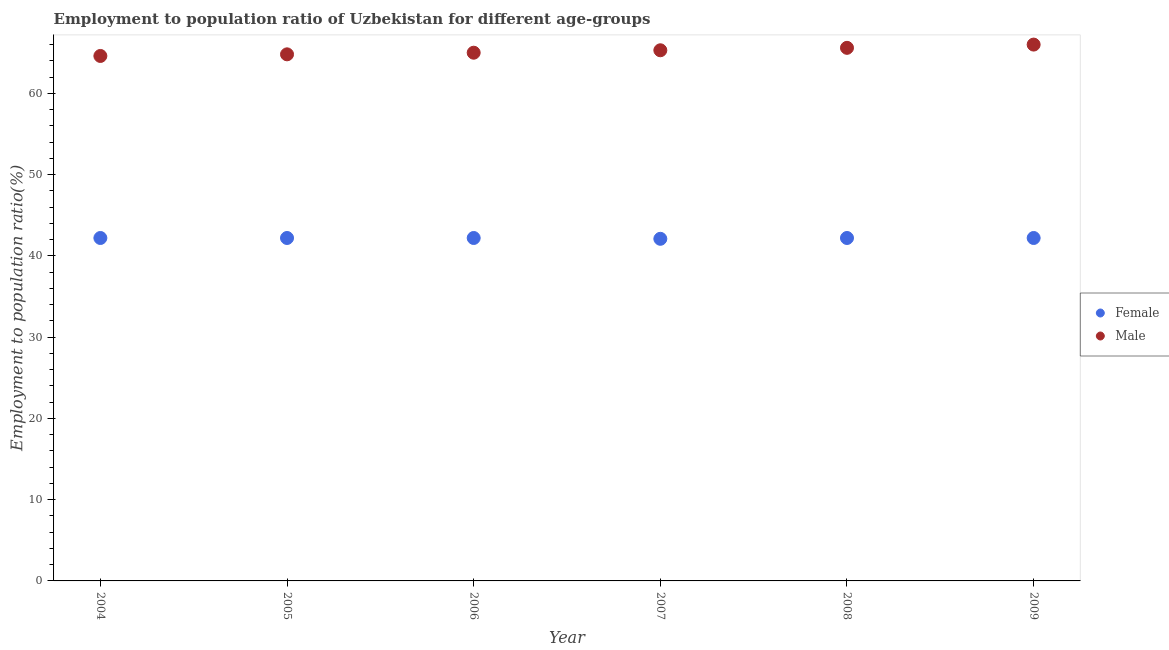Is the number of dotlines equal to the number of legend labels?
Provide a succinct answer. Yes. What is the employment to population ratio(female) in 2006?
Make the answer very short. 42.2. Across all years, what is the minimum employment to population ratio(male)?
Give a very brief answer. 64.6. In which year was the employment to population ratio(male) minimum?
Give a very brief answer. 2004. What is the total employment to population ratio(female) in the graph?
Ensure brevity in your answer.  253.1. What is the difference between the employment to population ratio(female) in 2006 and that in 2008?
Provide a succinct answer. 0. What is the difference between the employment to population ratio(male) in 2007 and the employment to population ratio(female) in 2008?
Provide a short and direct response. 23.1. What is the average employment to population ratio(female) per year?
Your response must be concise. 42.18. In the year 2004, what is the difference between the employment to population ratio(female) and employment to population ratio(male)?
Ensure brevity in your answer.  -22.4. What is the ratio of the employment to population ratio(male) in 2007 to that in 2009?
Keep it short and to the point. 0.99. Is the employment to population ratio(male) in 2004 less than that in 2009?
Provide a succinct answer. Yes. Is the difference between the employment to population ratio(male) in 2007 and 2008 greater than the difference between the employment to population ratio(female) in 2007 and 2008?
Your answer should be very brief. No. What is the difference between the highest and the second highest employment to population ratio(male)?
Give a very brief answer. 0.4. What is the difference between the highest and the lowest employment to population ratio(female)?
Keep it short and to the point. 0.1. Does the employment to population ratio(male) monotonically increase over the years?
Provide a succinct answer. Yes. How many years are there in the graph?
Offer a very short reply. 6. What is the difference between two consecutive major ticks on the Y-axis?
Offer a very short reply. 10. Does the graph contain any zero values?
Offer a very short reply. No. Does the graph contain grids?
Offer a terse response. No. Where does the legend appear in the graph?
Provide a short and direct response. Center right. How are the legend labels stacked?
Ensure brevity in your answer.  Vertical. What is the title of the graph?
Offer a terse response. Employment to population ratio of Uzbekistan for different age-groups. Does "Quality of trade" appear as one of the legend labels in the graph?
Make the answer very short. No. What is the label or title of the X-axis?
Make the answer very short. Year. What is the Employment to population ratio(%) in Female in 2004?
Your response must be concise. 42.2. What is the Employment to population ratio(%) in Male in 2004?
Offer a terse response. 64.6. What is the Employment to population ratio(%) of Female in 2005?
Give a very brief answer. 42.2. What is the Employment to population ratio(%) in Male in 2005?
Provide a succinct answer. 64.8. What is the Employment to population ratio(%) of Female in 2006?
Your answer should be compact. 42.2. What is the Employment to population ratio(%) in Male in 2006?
Offer a terse response. 65. What is the Employment to population ratio(%) in Female in 2007?
Offer a very short reply. 42.1. What is the Employment to population ratio(%) in Male in 2007?
Give a very brief answer. 65.3. What is the Employment to population ratio(%) of Female in 2008?
Keep it short and to the point. 42.2. What is the Employment to population ratio(%) in Male in 2008?
Your response must be concise. 65.6. What is the Employment to population ratio(%) in Female in 2009?
Your response must be concise. 42.2. Across all years, what is the maximum Employment to population ratio(%) of Female?
Ensure brevity in your answer.  42.2. Across all years, what is the maximum Employment to population ratio(%) of Male?
Your answer should be compact. 66. Across all years, what is the minimum Employment to population ratio(%) in Female?
Provide a succinct answer. 42.1. Across all years, what is the minimum Employment to population ratio(%) of Male?
Provide a short and direct response. 64.6. What is the total Employment to population ratio(%) of Female in the graph?
Offer a very short reply. 253.1. What is the total Employment to population ratio(%) in Male in the graph?
Offer a terse response. 391.3. What is the difference between the Employment to population ratio(%) of Female in 2004 and that in 2005?
Provide a succinct answer. 0. What is the difference between the Employment to population ratio(%) of Male in 2004 and that in 2005?
Ensure brevity in your answer.  -0.2. What is the difference between the Employment to population ratio(%) in Female in 2004 and that in 2006?
Give a very brief answer. 0. What is the difference between the Employment to population ratio(%) in Male in 2004 and that in 2007?
Provide a short and direct response. -0.7. What is the difference between the Employment to population ratio(%) in Male in 2004 and that in 2008?
Offer a terse response. -1. What is the difference between the Employment to population ratio(%) in Female in 2005 and that in 2006?
Your answer should be compact. 0. What is the difference between the Employment to population ratio(%) of Male in 2005 and that in 2006?
Your answer should be very brief. -0.2. What is the difference between the Employment to population ratio(%) of Male in 2005 and that in 2008?
Offer a terse response. -0.8. What is the difference between the Employment to population ratio(%) in Male in 2005 and that in 2009?
Keep it short and to the point. -1.2. What is the difference between the Employment to population ratio(%) in Female in 2006 and that in 2007?
Offer a very short reply. 0.1. What is the difference between the Employment to population ratio(%) of Male in 2006 and that in 2007?
Keep it short and to the point. -0.3. What is the difference between the Employment to population ratio(%) of Female in 2006 and that in 2008?
Make the answer very short. 0. What is the difference between the Employment to population ratio(%) of Male in 2006 and that in 2008?
Give a very brief answer. -0.6. What is the difference between the Employment to population ratio(%) in Female in 2006 and that in 2009?
Provide a succinct answer. 0. What is the difference between the Employment to population ratio(%) of Female in 2007 and that in 2008?
Give a very brief answer. -0.1. What is the difference between the Employment to population ratio(%) of Male in 2007 and that in 2008?
Ensure brevity in your answer.  -0.3. What is the difference between the Employment to population ratio(%) of Male in 2008 and that in 2009?
Provide a succinct answer. -0.4. What is the difference between the Employment to population ratio(%) of Female in 2004 and the Employment to population ratio(%) of Male in 2005?
Give a very brief answer. -22.6. What is the difference between the Employment to population ratio(%) in Female in 2004 and the Employment to population ratio(%) in Male in 2006?
Give a very brief answer. -22.8. What is the difference between the Employment to population ratio(%) in Female in 2004 and the Employment to population ratio(%) in Male in 2007?
Keep it short and to the point. -23.1. What is the difference between the Employment to population ratio(%) of Female in 2004 and the Employment to population ratio(%) of Male in 2008?
Make the answer very short. -23.4. What is the difference between the Employment to population ratio(%) in Female in 2004 and the Employment to population ratio(%) in Male in 2009?
Offer a terse response. -23.8. What is the difference between the Employment to population ratio(%) of Female in 2005 and the Employment to population ratio(%) of Male in 2006?
Your response must be concise. -22.8. What is the difference between the Employment to population ratio(%) in Female in 2005 and the Employment to population ratio(%) in Male in 2007?
Provide a short and direct response. -23.1. What is the difference between the Employment to population ratio(%) in Female in 2005 and the Employment to population ratio(%) in Male in 2008?
Provide a succinct answer. -23.4. What is the difference between the Employment to population ratio(%) of Female in 2005 and the Employment to population ratio(%) of Male in 2009?
Your answer should be very brief. -23.8. What is the difference between the Employment to population ratio(%) in Female in 2006 and the Employment to population ratio(%) in Male in 2007?
Your answer should be very brief. -23.1. What is the difference between the Employment to population ratio(%) of Female in 2006 and the Employment to population ratio(%) of Male in 2008?
Give a very brief answer. -23.4. What is the difference between the Employment to population ratio(%) of Female in 2006 and the Employment to population ratio(%) of Male in 2009?
Give a very brief answer. -23.8. What is the difference between the Employment to population ratio(%) of Female in 2007 and the Employment to population ratio(%) of Male in 2008?
Make the answer very short. -23.5. What is the difference between the Employment to population ratio(%) in Female in 2007 and the Employment to population ratio(%) in Male in 2009?
Offer a terse response. -23.9. What is the difference between the Employment to population ratio(%) of Female in 2008 and the Employment to population ratio(%) of Male in 2009?
Provide a short and direct response. -23.8. What is the average Employment to population ratio(%) of Female per year?
Your answer should be compact. 42.18. What is the average Employment to population ratio(%) of Male per year?
Your response must be concise. 65.22. In the year 2004, what is the difference between the Employment to population ratio(%) of Female and Employment to population ratio(%) of Male?
Keep it short and to the point. -22.4. In the year 2005, what is the difference between the Employment to population ratio(%) of Female and Employment to population ratio(%) of Male?
Give a very brief answer. -22.6. In the year 2006, what is the difference between the Employment to population ratio(%) of Female and Employment to population ratio(%) of Male?
Ensure brevity in your answer.  -22.8. In the year 2007, what is the difference between the Employment to population ratio(%) in Female and Employment to population ratio(%) in Male?
Your answer should be compact. -23.2. In the year 2008, what is the difference between the Employment to population ratio(%) in Female and Employment to population ratio(%) in Male?
Make the answer very short. -23.4. In the year 2009, what is the difference between the Employment to population ratio(%) in Female and Employment to population ratio(%) in Male?
Provide a short and direct response. -23.8. What is the ratio of the Employment to population ratio(%) in Male in 2004 to that in 2005?
Your answer should be compact. 1. What is the ratio of the Employment to population ratio(%) of Male in 2004 to that in 2006?
Make the answer very short. 0.99. What is the ratio of the Employment to population ratio(%) of Male in 2004 to that in 2007?
Make the answer very short. 0.99. What is the ratio of the Employment to population ratio(%) of Male in 2004 to that in 2008?
Offer a very short reply. 0.98. What is the ratio of the Employment to population ratio(%) in Male in 2004 to that in 2009?
Offer a very short reply. 0.98. What is the ratio of the Employment to population ratio(%) of Female in 2005 to that in 2007?
Keep it short and to the point. 1. What is the ratio of the Employment to population ratio(%) of Male in 2005 to that in 2007?
Your answer should be compact. 0.99. What is the ratio of the Employment to population ratio(%) of Male in 2005 to that in 2008?
Your answer should be compact. 0.99. What is the ratio of the Employment to population ratio(%) of Female in 2005 to that in 2009?
Give a very brief answer. 1. What is the ratio of the Employment to population ratio(%) in Male in 2005 to that in 2009?
Ensure brevity in your answer.  0.98. What is the ratio of the Employment to population ratio(%) of Male in 2006 to that in 2007?
Provide a succinct answer. 1. What is the ratio of the Employment to population ratio(%) of Female in 2006 to that in 2008?
Your response must be concise. 1. What is the ratio of the Employment to population ratio(%) of Male in 2006 to that in 2008?
Keep it short and to the point. 0.99. What is the ratio of the Employment to population ratio(%) of Female in 2006 to that in 2009?
Offer a terse response. 1. What is the ratio of the Employment to population ratio(%) in Male in 2006 to that in 2009?
Make the answer very short. 0.98. What is the ratio of the Employment to population ratio(%) in Female in 2007 to that in 2008?
Your response must be concise. 1. What is the ratio of the Employment to population ratio(%) of Male in 2007 to that in 2008?
Provide a short and direct response. 1. What is the ratio of the Employment to population ratio(%) in Female in 2008 to that in 2009?
Offer a terse response. 1. What is the ratio of the Employment to population ratio(%) of Male in 2008 to that in 2009?
Provide a succinct answer. 0.99. What is the difference between the highest and the second highest Employment to population ratio(%) in Male?
Ensure brevity in your answer.  0.4. What is the difference between the highest and the lowest Employment to population ratio(%) of Female?
Give a very brief answer. 0.1. What is the difference between the highest and the lowest Employment to population ratio(%) in Male?
Keep it short and to the point. 1.4. 